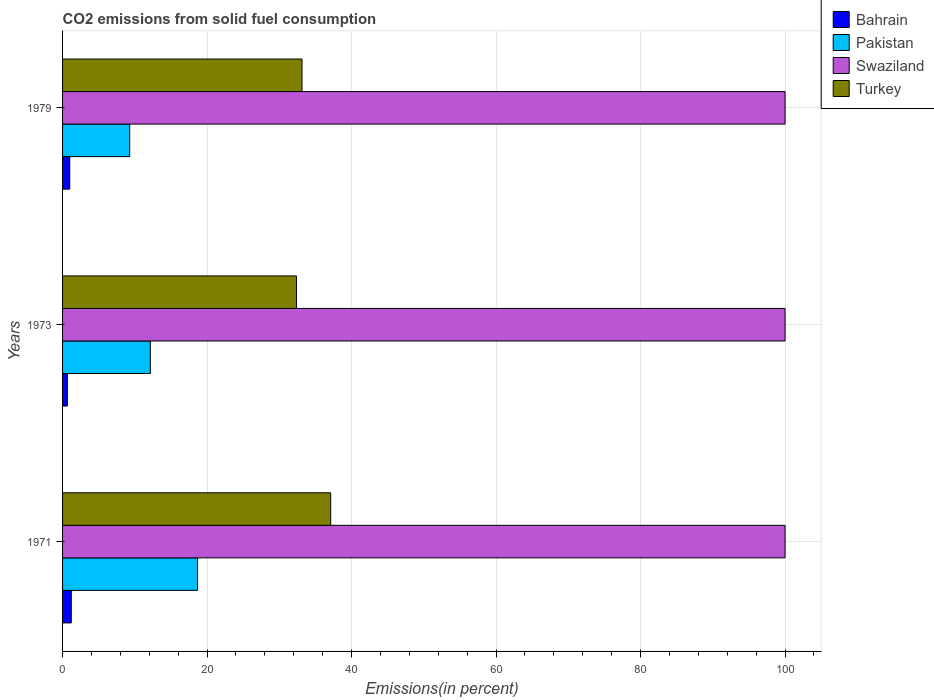How many groups of bars are there?
Give a very brief answer. 3. Are the number of bars per tick equal to the number of legend labels?
Give a very brief answer. Yes. How many bars are there on the 1st tick from the top?
Your answer should be compact. 4. What is the label of the 1st group of bars from the top?
Provide a succinct answer. 1979. In how many cases, is the number of bars for a given year not equal to the number of legend labels?
Offer a very short reply. 0. What is the total CO2 emitted in Turkey in 1973?
Keep it short and to the point. 32.38. Across all years, what is the maximum total CO2 emitted in Turkey?
Offer a terse response. 37.11. Across all years, what is the minimum total CO2 emitted in Swaziland?
Provide a short and direct response. 100. In which year was the total CO2 emitted in Swaziland minimum?
Your response must be concise. 1971. What is the total total CO2 emitted in Turkey in the graph?
Ensure brevity in your answer.  102.63. What is the difference between the total CO2 emitted in Pakistan in 1971 and that in 1973?
Offer a terse response. 6.54. What is the difference between the total CO2 emitted in Turkey in 1971 and the total CO2 emitted in Swaziland in 1973?
Offer a terse response. -62.89. What is the average total CO2 emitted in Turkey per year?
Your answer should be very brief. 34.21. In the year 1979, what is the difference between the total CO2 emitted in Turkey and total CO2 emitted in Pakistan?
Keep it short and to the point. 23.85. What is the ratio of the total CO2 emitted in Pakistan in 1971 to that in 1979?
Offer a very short reply. 2.01. What is the difference between the highest and the second highest total CO2 emitted in Bahrain?
Offer a terse response. 0.21. What is the difference between the highest and the lowest total CO2 emitted in Pakistan?
Your answer should be very brief. 9.39. In how many years, is the total CO2 emitted in Swaziland greater than the average total CO2 emitted in Swaziland taken over all years?
Give a very brief answer. 0. Is it the case that in every year, the sum of the total CO2 emitted in Pakistan and total CO2 emitted in Swaziland is greater than the sum of total CO2 emitted in Bahrain and total CO2 emitted in Turkey?
Offer a terse response. Yes. What does the 3rd bar from the top in 1971 represents?
Ensure brevity in your answer.  Pakistan. What does the 2nd bar from the bottom in 1973 represents?
Your answer should be very brief. Pakistan. Is it the case that in every year, the sum of the total CO2 emitted in Turkey and total CO2 emitted in Bahrain is greater than the total CO2 emitted in Pakistan?
Offer a very short reply. Yes. How many years are there in the graph?
Make the answer very short. 3. Are the values on the major ticks of X-axis written in scientific E-notation?
Make the answer very short. No. Does the graph contain any zero values?
Give a very brief answer. No. Where does the legend appear in the graph?
Offer a very short reply. Top right. How many legend labels are there?
Offer a very short reply. 4. What is the title of the graph?
Provide a succinct answer. CO2 emissions from solid fuel consumption. Does "Uganda" appear as one of the legend labels in the graph?
Provide a succinct answer. No. What is the label or title of the X-axis?
Your answer should be compact. Emissions(in percent). What is the label or title of the Y-axis?
Offer a terse response. Years. What is the Emissions(in percent) in Bahrain in 1971?
Offer a terse response. 1.21. What is the Emissions(in percent) of Pakistan in 1971?
Ensure brevity in your answer.  18.69. What is the Emissions(in percent) in Turkey in 1971?
Your answer should be very brief. 37.11. What is the Emissions(in percent) in Bahrain in 1973?
Make the answer very short. 0.66. What is the Emissions(in percent) of Pakistan in 1973?
Give a very brief answer. 12.15. What is the Emissions(in percent) in Swaziland in 1973?
Your answer should be very brief. 100. What is the Emissions(in percent) of Turkey in 1973?
Your answer should be compact. 32.38. What is the Emissions(in percent) of Bahrain in 1979?
Your response must be concise. 0.99. What is the Emissions(in percent) of Pakistan in 1979?
Ensure brevity in your answer.  9.29. What is the Emissions(in percent) of Swaziland in 1979?
Provide a succinct answer. 100. What is the Emissions(in percent) of Turkey in 1979?
Provide a short and direct response. 33.14. Across all years, what is the maximum Emissions(in percent) in Bahrain?
Offer a terse response. 1.21. Across all years, what is the maximum Emissions(in percent) in Pakistan?
Offer a very short reply. 18.69. Across all years, what is the maximum Emissions(in percent) in Turkey?
Provide a succinct answer. 37.11. Across all years, what is the minimum Emissions(in percent) of Bahrain?
Provide a short and direct response. 0.66. Across all years, what is the minimum Emissions(in percent) of Pakistan?
Provide a short and direct response. 9.29. Across all years, what is the minimum Emissions(in percent) in Swaziland?
Keep it short and to the point. 100. Across all years, what is the minimum Emissions(in percent) of Turkey?
Provide a succinct answer. 32.38. What is the total Emissions(in percent) of Bahrain in the graph?
Ensure brevity in your answer.  2.86. What is the total Emissions(in percent) of Pakistan in the graph?
Your answer should be very brief. 40.13. What is the total Emissions(in percent) in Swaziland in the graph?
Give a very brief answer. 300. What is the total Emissions(in percent) of Turkey in the graph?
Offer a terse response. 102.63. What is the difference between the Emissions(in percent) of Bahrain in 1971 and that in 1973?
Provide a short and direct response. 0.54. What is the difference between the Emissions(in percent) in Pakistan in 1971 and that in 1973?
Ensure brevity in your answer.  6.54. What is the difference between the Emissions(in percent) in Swaziland in 1971 and that in 1973?
Offer a terse response. 0. What is the difference between the Emissions(in percent) of Turkey in 1971 and that in 1973?
Your response must be concise. 4.74. What is the difference between the Emissions(in percent) of Bahrain in 1971 and that in 1979?
Offer a very short reply. 0.21. What is the difference between the Emissions(in percent) in Pakistan in 1971 and that in 1979?
Your answer should be compact. 9.39. What is the difference between the Emissions(in percent) in Turkey in 1971 and that in 1979?
Your answer should be compact. 3.97. What is the difference between the Emissions(in percent) of Bahrain in 1973 and that in 1979?
Offer a very short reply. -0.33. What is the difference between the Emissions(in percent) of Pakistan in 1973 and that in 1979?
Your answer should be very brief. 2.86. What is the difference between the Emissions(in percent) of Swaziland in 1973 and that in 1979?
Your answer should be compact. 0. What is the difference between the Emissions(in percent) in Turkey in 1973 and that in 1979?
Make the answer very short. -0.76. What is the difference between the Emissions(in percent) in Bahrain in 1971 and the Emissions(in percent) in Pakistan in 1973?
Give a very brief answer. -10.95. What is the difference between the Emissions(in percent) of Bahrain in 1971 and the Emissions(in percent) of Swaziland in 1973?
Make the answer very short. -98.79. What is the difference between the Emissions(in percent) of Bahrain in 1971 and the Emissions(in percent) of Turkey in 1973?
Provide a short and direct response. -31.17. What is the difference between the Emissions(in percent) in Pakistan in 1971 and the Emissions(in percent) in Swaziland in 1973?
Your response must be concise. -81.31. What is the difference between the Emissions(in percent) in Pakistan in 1971 and the Emissions(in percent) in Turkey in 1973?
Your response must be concise. -13.69. What is the difference between the Emissions(in percent) in Swaziland in 1971 and the Emissions(in percent) in Turkey in 1973?
Provide a succinct answer. 67.62. What is the difference between the Emissions(in percent) of Bahrain in 1971 and the Emissions(in percent) of Pakistan in 1979?
Offer a very short reply. -8.09. What is the difference between the Emissions(in percent) in Bahrain in 1971 and the Emissions(in percent) in Swaziland in 1979?
Your answer should be compact. -98.79. What is the difference between the Emissions(in percent) of Bahrain in 1971 and the Emissions(in percent) of Turkey in 1979?
Make the answer very short. -31.93. What is the difference between the Emissions(in percent) of Pakistan in 1971 and the Emissions(in percent) of Swaziland in 1979?
Your answer should be very brief. -81.31. What is the difference between the Emissions(in percent) of Pakistan in 1971 and the Emissions(in percent) of Turkey in 1979?
Your answer should be very brief. -14.45. What is the difference between the Emissions(in percent) in Swaziland in 1971 and the Emissions(in percent) in Turkey in 1979?
Offer a very short reply. 66.86. What is the difference between the Emissions(in percent) in Bahrain in 1973 and the Emissions(in percent) in Pakistan in 1979?
Ensure brevity in your answer.  -8.63. What is the difference between the Emissions(in percent) in Bahrain in 1973 and the Emissions(in percent) in Swaziland in 1979?
Offer a very short reply. -99.34. What is the difference between the Emissions(in percent) in Bahrain in 1973 and the Emissions(in percent) in Turkey in 1979?
Give a very brief answer. -32.48. What is the difference between the Emissions(in percent) in Pakistan in 1973 and the Emissions(in percent) in Swaziland in 1979?
Provide a succinct answer. -87.85. What is the difference between the Emissions(in percent) in Pakistan in 1973 and the Emissions(in percent) in Turkey in 1979?
Make the answer very short. -20.99. What is the difference between the Emissions(in percent) of Swaziland in 1973 and the Emissions(in percent) of Turkey in 1979?
Make the answer very short. 66.86. What is the average Emissions(in percent) of Bahrain per year?
Ensure brevity in your answer.  0.95. What is the average Emissions(in percent) in Pakistan per year?
Your response must be concise. 13.38. What is the average Emissions(in percent) in Swaziland per year?
Offer a terse response. 100. What is the average Emissions(in percent) in Turkey per year?
Ensure brevity in your answer.  34.21. In the year 1971, what is the difference between the Emissions(in percent) of Bahrain and Emissions(in percent) of Pakistan?
Offer a terse response. -17.48. In the year 1971, what is the difference between the Emissions(in percent) of Bahrain and Emissions(in percent) of Swaziland?
Keep it short and to the point. -98.79. In the year 1971, what is the difference between the Emissions(in percent) of Bahrain and Emissions(in percent) of Turkey?
Offer a very short reply. -35.91. In the year 1971, what is the difference between the Emissions(in percent) of Pakistan and Emissions(in percent) of Swaziland?
Your answer should be compact. -81.31. In the year 1971, what is the difference between the Emissions(in percent) of Pakistan and Emissions(in percent) of Turkey?
Ensure brevity in your answer.  -18.43. In the year 1971, what is the difference between the Emissions(in percent) of Swaziland and Emissions(in percent) of Turkey?
Your response must be concise. 62.89. In the year 1973, what is the difference between the Emissions(in percent) of Bahrain and Emissions(in percent) of Pakistan?
Offer a terse response. -11.49. In the year 1973, what is the difference between the Emissions(in percent) in Bahrain and Emissions(in percent) in Swaziland?
Provide a short and direct response. -99.34. In the year 1973, what is the difference between the Emissions(in percent) in Bahrain and Emissions(in percent) in Turkey?
Your answer should be compact. -31.71. In the year 1973, what is the difference between the Emissions(in percent) in Pakistan and Emissions(in percent) in Swaziland?
Make the answer very short. -87.85. In the year 1973, what is the difference between the Emissions(in percent) in Pakistan and Emissions(in percent) in Turkey?
Your answer should be compact. -20.22. In the year 1973, what is the difference between the Emissions(in percent) of Swaziland and Emissions(in percent) of Turkey?
Make the answer very short. 67.62. In the year 1979, what is the difference between the Emissions(in percent) in Bahrain and Emissions(in percent) in Pakistan?
Offer a terse response. -8.3. In the year 1979, what is the difference between the Emissions(in percent) of Bahrain and Emissions(in percent) of Swaziland?
Offer a very short reply. -99.01. In the year 1979, what is the difference between the Emissions(in percent) in Bahrain and Emissions(in percent) in Turkey?
Provide a short and direct response. -32.15. In the year 1979, what is the difference between the Emissions(in percent) in Pakistan and Emissions(in percent) in Swaziland?
Offer a terse response. -90.71. In the year 1979, what is the difference between the Emissions(in percent) in Pakistan and Emissions(in percent) in Turkey?
Your answer should be very brief. -23.85. In the year 1979, what is the difference between the Emissions(in percent) in Swaziland and Emissions(in percent) in Turkey?
Offer a very short reply. 66.86. What is the ratio of the Emissions(in percent) in Bahrain in 1971 to that in 1973?
Offer a terse response. 1.82. What is the ratio of the Emissions(in percent) of Pakistan in 1971 to that in 1973?
Ensure brevity in your answer.  1.54. What is the ratio of the Emissions(in percent) of Swaziland in 1971 to that in 1973?
Your response must be concise. 1. What is the ratio of the Emissions(in percent) in Turkey in 1971 to that in 1973?
Provide a succinct answer. 1.15. What is the ratio of the Emissions(in percent) in Bahrain in 1971 to that in 1979?
Make the answer very short. 1.22. What is the ratio of the Emissions(in percent) of Pakistan in 1971 to that in 1979?
Offer a very short reply. 2.01. What is the ratio of the Emissions(in percent) in Turkey in 1971 to that in 1979?
Provide a succinct answer. 1.12. What is the ratio of the Emissions(in percent) of Bahrain in 1973 to that in 1979?
Provide a succinct answer. 0.67. What is the ratio of the Emissions(in percent) of Pakistan in 1973 to that in 1979?
Your answer should be very brief. 1.31. What is the ratio of the Emissions(in percent) in Swaziland in 1973 to that in 1979?
Offer a very short reply. 1. What is the difference between the highest and the second highest Emissions(in percent) in Bahrain?
Provide a succinct answer. 0.21. What is the difference between the highest and the second highest Emissions(in percent) of Pakistan?
Your response must be concise. 6.54. What is the difference between the highest and the second highest Emissions(in percent) of Swaziland?
Your response must be concise. 0. What is the difference between the highest and the second highest Emissions(in percent) of Turkey?
Make the answer very short. 3.97. What is the difference between the highest and the lowest Emissions(in percent) in Bahrain?
Your answer should be very brief. 0.54. What is the difference between the highest and the lowest Emissions(in percent) in Pakistan?
Ensure brevity in your answer.  9.39. What is the difference between the highest and the lowest Emissions(in percent) in Swaziland?
Your response must be concise. 0. What is the difference between the highest and the lowest Emissions(in percent) in Turkey?
Give a very brief answer. 4.74. 